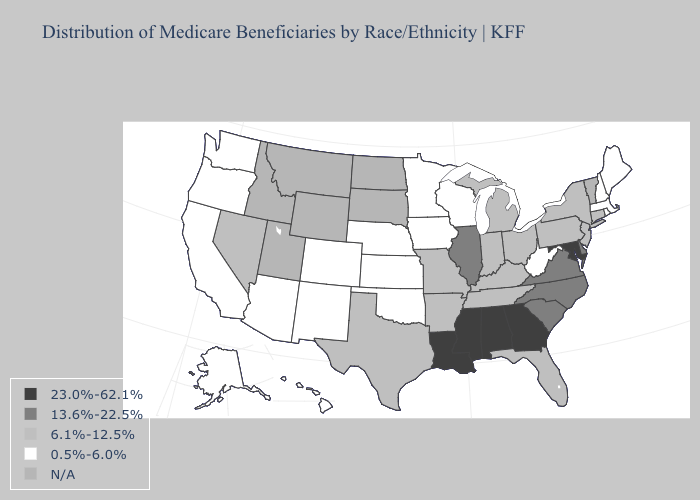Which states have the lowest value in the USA?
Write a very short answer. Alaska, Arizona, California, Colorado, Hawaii, Iowa, Kansas, Maine, Massachusetts, Minnesota, Nebraska, New Hampshire, New Mexico, Oklahoma, Oregon, Rhode Island, Washington, West Virginia, Wisconsin. Which states have the lowest value in the West?
Be succinct. Alaska, Arizona, California, Colorado, Hawaii, New Mexico, Oregon, Washington. Among the states that border North Carolina , does Tennessee have the lowest value?
Give a very brief answer. Yes. What is the lowest value in the USA?
Quick response, please. 0.5%-6.0%. Among the states that border Iowa , which have the lowest value?
Concise answer only. Minnesota, Nebraska, Wisconsin. Does the first symbol in the legend represent the smallest category?
Give a very brief answer. No. What is the highest value in the USA?
Give a very brief answer. 23.0%-62.1%. What is the value of Maryland?
Give a very brief answer. 23.0%-62.1%. Name the states that have a value in the range 6.1%-12.5%?
Quick response, please. Arkansas, Connecticut, Florida, Indiana, Kentucky, Michigan, Missouri, Nevada, New Jersey, New York, Ohio, Pennsylvania, Tennessee, Texas. Is the legend a continuous bar?
Write a very short answer. No. Name the states that have a value in the range 6.1%-12.5%?
Keep it brief. Arkansas, Connecticut, Florida, Indiana, Kentucky, Michigan, Missouri, Nevada, New Jersey, New York, Ohio, Pennsylvania, Tennessee, Texas. 